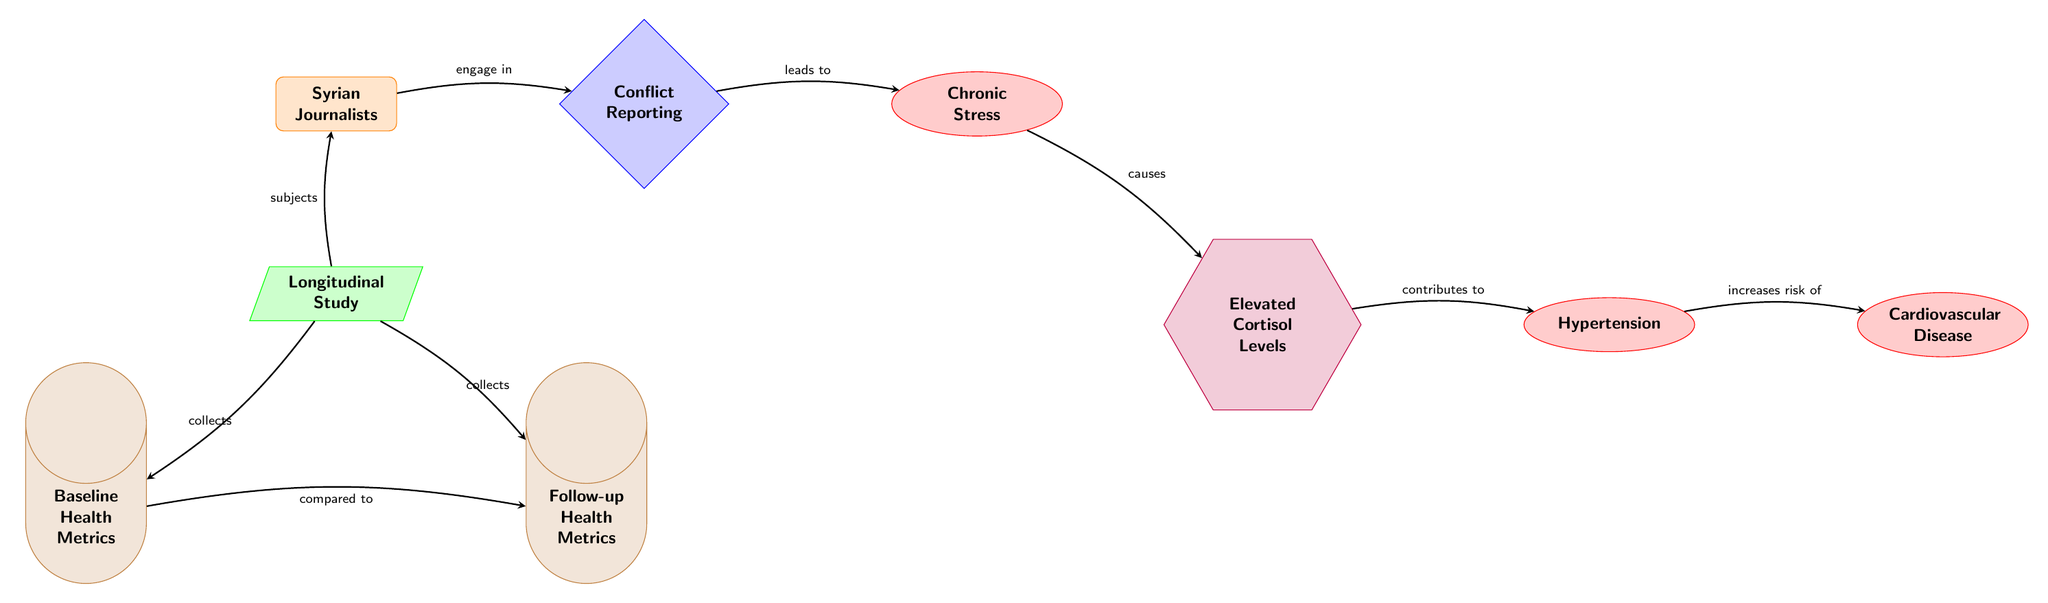What kind of study design is used in the diagram? The diagram specifies "Longitudinal Study" at the bottom, indicating the methodology employed in the research.
Answer: Longitudinal Study How many conditions are there in the diagram? By examining the nodes, there are three conditions: Chronic Stress, Hypertension, and Cardiovascular Disease.
Answer: 3 What do Syrian journalists engage in according to the diagram? The diagram explicitly states that Syrian journalists "engage in" Conflict Reporting, shown as an arrow pointing towards Conflict Reporting.
Answer: Conflict Reporting What is the end-point shown in the diagram? The last condition pointing rightward is "Cardiovascular Disease", in the sequence of relationships depicted.
Answer: Cardiovascular Disease What does Chronic Stress cause, based on the diagram's flow? The arrow from Chronic Stress points to Elevated Cortisol Levels, indicating that Chronic Stress causes Elevated Cortisol Levels.
Answer: Elevated Cortisol Levels What health metrics are collected in this study? The diagram lists two types of health metrics: Baseline Health Metrics and Follow-up Health Metrics, shown in cylinders at the bottom of the diagram.
Answer: Baseline Health Metrics, Follow-up Health Metrics Which factor contributes to Hypertension? The arrow from Elevated Cortisol Levels points to Hypertension, indicating that Elevated Cortisol Levels contribute to Hypertension.
Answer: Elevated Cortisol Levels What kind of health impact does conflict reporting have on the journalists over time? The flow of the diagram suggests that Conflict Reporting leads to Chronic Stress, which subsequently increases the risk of Cardiovascular Disease, illustrating a negative impact on health.
Answer: Increased risk of Cardiovascular Disease How are the health metrics compared in the study? An arrow from Baseline Health Metrics to Follow-up Health Metrics indicates they are compared, which is key for longitudinal analysis in the study.
Answer: Compared to 